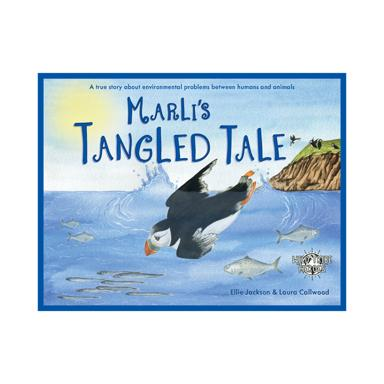Who are the authors of the book? The book 'Marli's Tangled Tale' is authored by Ellie Jackson, who wrote the engaging narrative, and illustrated by Loura Collwood, who brought the characters and scenes to life with her artistic skills. 